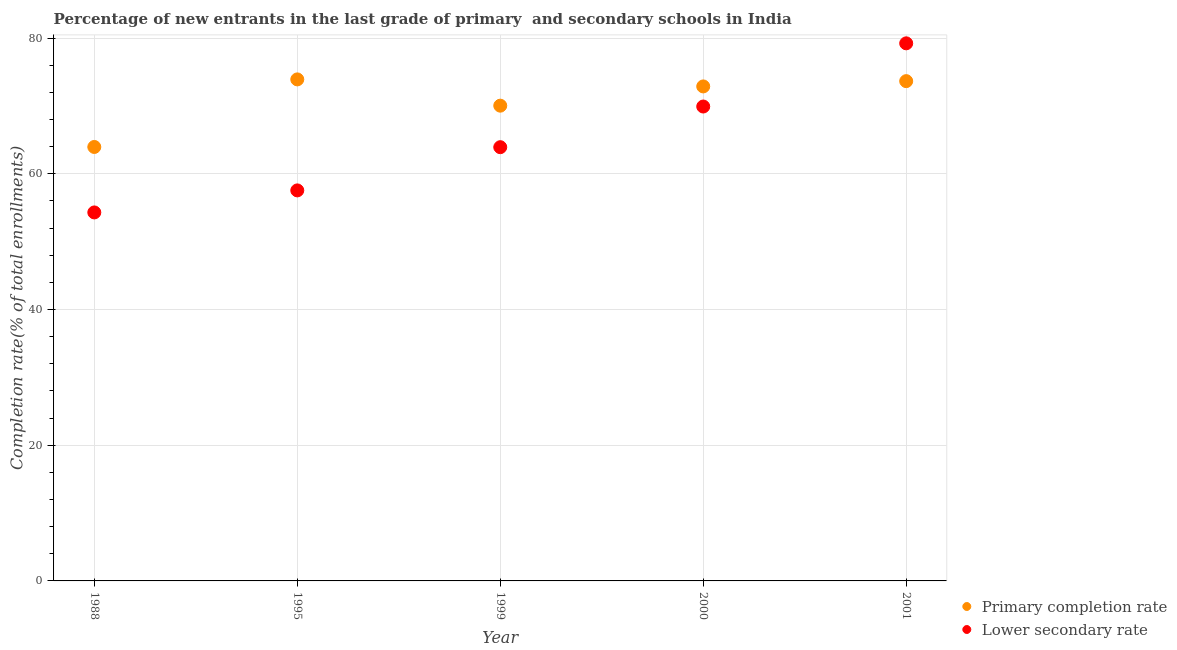How many different coloured dotlines are there?
Make the answer very short. 2. What is the completion rate in primary schools in 1988?
Your answer should be compact. 63.96. Across all years, what is the maximum completion rate in primary schools?
Provide a short and direct response. 73.92. Across all years, what is the minimum completion rate in secondary schools?
Your answer should be very brief. 54.31. In which year was the completion rate in primary schools minimum?
Your answer should be compact. 1988. What is the total completion rate in primary schools in the graph?
Offer a very short reply. 354.47. What is the difference between the completion rate in secondary schools in 1988 and that in 2000?
Offer a very short reply. -15.61. What is the difference between the completion rate in secondary schools in 2001 and the completion rate in primary schools in 1988?
Your answer should be very brief. 15.28. What is the average completion rate in primary schools per year?
Your answer should be very brief. 70.89. In the year 2001, what is the difference between the completion rate in primary schools and completion rate in secondary schools?
Offer a very short reply. -5.57. What is the ratio of the completion rate in primary schools in 1988 to that in 2001?
Keep it short and to the point. 0.87. Is the completion rate in secondary schools in 1988 less than that in 1995?
Your answer should be very brief. Yes. What is the difference between the highest and the second highest completion rate in secondary schools?
Give a very brief answer. 9.31. What is the difference between the highest and the lowest completion rate in primary schools?
Ensure brevity in your answer.  9.96. Is the sum of the completion rate in primary schools in 1999 and 2001 greater than the maximum completion rate in secondary schools across all years?
Give a very brief answer. Yes. Is the completion rate in secondary schools strictly greater than the completion rate in primary schools over the years?
Ensure brevity in your answer.  No. How many years are there in the graph?
Offer a terse response. 5. What is the difference between two consecutive major ticks on the Y-axis?
Give a very brief answer. 20. How are the legend labels stacked?
Provide a short and direct response. Vertical. What is the title of the graph?
Provide a succinct answer. Percentage of new entrants in the last grade of primary  and secondary schools in India. Does "Grants" appear as one of the legend labels in the graph?
Your answer should be compact. No. What is the label or title of the Y-axis?
Your response must be concise. Completion rate(% of total enrollments). What is the Completion rate(% of total enrollments) of Primary completion rate in 1988?
Provide a short and direct response. 63.96. What is the Completion rate(% of total enrollments) in Lower secondary rate in 1988?
Make the answer very short. 54.31. What is the Completion rate(% of total enrollments) of Primary completion rate in 1995?
Make the answer very short. 73.92. What is the Completion rate(% of total enrollments) in Lower secondary rate in 1995?
Offer a terse response. 57.56. What is the Completion rate(% of total enrollments) in Primary completion rate in 1999?
Offer a very short reply. 70.05. What is the Completion rate(% of total enrollments) of Lower secondary rate in 1999?
Your answer should be very brief. 63.93. What is the Completion rate(% of total enrollments) in Primary completion rate in 2000?
Provide a short and direct response. 72.88. What is the Completion rate(% of total enrollments) in Lower secondary rate in 2000?
Your response must be concise. 69.92. What is the Completion rate(% of total enrollments) of Primary completion rate in 2001?
Give a very brief answer. 73.66. What is the Completion rate(% of total enrollments) in Lower secondary rate in 2001?
Provide a short and direct response. 79.24. Across all years, what is the maximum Completion rate(% of total enrollments) in Primary completion rate?
Give a very brief answer. 73.92. Across all years, what is the maximum Completion rate(% of total enrollments) in Lower secondary rate?
Your answer should be compact. 79.24. Across all years, what is the minimum Completion rate(% of total enrollments) of Primary completion rate?
Offer a terse response. 63.96. Across all years, what is the minimum Completion rate(% of total enrollments) in Lower secondary rate?
Your answer should be very brief. 54.31. What is the total Completion rate(% of total enrollments) in Primary completion rate in the graph?
Your answer should be compact. 354.47. What is the total Completion rate(% of total enrollments) of Lower secondary rate in the graph?
Offer a terse response. 324.96. What is the difference between the Completion rate(% of total enrollments) of Primary completion rate in 1988 and that in 1995?
Your answer should be compact. -9.96. What is the difference between the Completion rate(% of total enrollments) of Lower secondary rate in 1988 and that in 1995?
Offer a very short reply. -3.25. What is the difference between the Completion rate(% of total enrollments) of Primary completion rate in 1988 and that in 1999?
Provide a short and direct response. -6.09. What is the difference between the Completion rate(% of total enrollments) of Lower secondary rate in 1988 and that in 1999?
Provide a short and direct response. -9.62. What is the difference between the Completion rate(% of total enrollments) in Primary completion rate in 1988 and that in 2000?
Your answer should be compact. -8.92. What is the difference between the Completion rate(% of total enrollments) of Lower secondary rate in 1988 and that in 2000?
Your response must be concise. -15.61. What is the difference between the Completion rate(% of total enrollments) in Primary completion rate in 1988 and that in 2001?
Your answer should be very brief. -9.7. What is the difference between the Completion rate(% of total enrollments) in Lower secondary rate in 1988 and that in 2001?
Your answer should be compact. -24.92. What is the difference between the Completion rate(% of total enrollments) of Primary completion rate in 1995 and that in 1999?
Keep it short and to the point. 3.87. What is the difference between the Completion rate(% of total enrollments) in Lower secondary rate in 1995 and that in 1999?
Your answer should be compact. -6.37. What is the difference between the Completion rate(% of total enrollments) of Primary completion rate in 1995 and that in 2000?
Make the answer very short. 1.04. What is the difference between the Completion rate(% of total enrollments) in Lower secondary rate in 1995 and that in 2000?
Provide a succinct answer. -12.36. What is the difference between the Completion rate(% of total enrollments) of Primary completion rate in 1995 and that in 2001?
Make the answer very short. 0.26. What is the difference between the Completion rate(% of total enrollments) of Lower secondary rate in 1995 and that in 2001?
Provide a short and direct response. -21.68. What is the difference between the Completion rate(% of total enrollments) in Primary completion rate in 1999 and that in 2000?
Ensure brevity in your answer.  -2.84. What is the difference between the Completion rate(% of total enrollments) in Lower secondary rate in 1999 and that in 2000?
Make the answer very short. -5.99. What is the difference between the Completion rate(% of total enrollments) in Primary completion rate in 1999 and that in 2001?
Keep it short and to the point. -3.62. What is the difference between the Completion rate(% of total enrollments) of Lower secondary rate in 1999 and that in 2001?
Ensure brevity in your answer.  -15.31. What is the difference between the Completion rate(% of total enrollments) in Primary completion rate in 2000 and that in 2001?
Your answer should be compact. -0.78. What is the difference between the Completion rate(% of total enrollments) in Lower secondary rate in 2000 and that in 2001?
Your answer should be very brief. -9.31. What is the difference between the Completion rate(% of total enrollments) of Primary completion rate in 1988 and the Completion rate(% of total enrollments) of Lower secondary rate in 1995?
Provide a succinct answer. 6.4. What is the difference between the Completion rate(% of total enrollments) of Primary completion rate in 1988 and the Completion rate(% of total enrollments) of Lower secondary rate in 1999?
Offer a very short reply. 0.03. What is the difference between the Completion rate(% of total enrollments) in Primary completion rate in 1988 and the Completion rate(% of total enrollments) in Lower secondary rate in 2000?
Your answer should be very brief. -5.96. What is the difference between the Completion rate(% of total enrollments) of Primary completion rate in 1988 and the Completion rate(% of total enrollments) of Lower secondary rate in 2001?
Offer a very short reply. -15.28. What is the difference between the Completion rate(% of total enrollments) of Primary completion rate in 1995 and the Completion rate(% of total enrollments) of Lower secondary rate in 1999?
Your response must be concise. 9.99. What is the difference between the Completion rate(% of total enrollments) of Primary completion rate in 1995 and the Completion rate(% of total enrollments) of Lower secondary rate in 2000?
Your answer should be compact. 4. What is the difference between the Completion rate(% of total enrollments) of Primary completion rate in 1995 and the Completion rate(% of total enrollments) of Lower secondary rate in 2001?
Keep it short and to the point. -5.32. What is the difference between the Completion rate(% of total enrollments) in Primary completion rate in 1999 and the Completion rate(% of total enrollments) in Lower secondary rate in 2000?
Your answer should be very brief. 0.13. What is the difference between the Completion rate(% of total enrollments) of Primary completion rate in 1999 and the Completion rate(% of total enrollments) of Lower secondary rate in 2001?
Provide a short and direct response. -9.19. What is the difference between the Completion rate(% of total enrollments) of Primary completion rate in 2000 and the Completion rate(% of total enrollments) of Lower secondary rate in 2001?
Your response must be concise. -6.35. What is the average Completion rate(% of total enrollments) in Primary completion rate per year?
Provide a short and direct response. 70.89. What is the average Completion rate(% of total enrollments) in Lower secondary rate per year?
Give a very brief answer. 64.99. In the year 1988, what is the difference between the Completion rate(% of total enrollments) in Primary completion rate and Completion rate(% of total enrollments) in Lower secondary rate?
Give a very brief answer. 9.65. In the year 1995, what is the difference between the Completion rate(% of total enrollments) in Primary completion rate and Completion rate(% of total enrollments) in Lower secondary rate?
Your response must be concise. 16.36. In the year 1999, what is the difference between the Completion rate(% of total enrollments) of Primary completion rate and Completion rate(% of total enrollments) of Lower secondary rate?
Make the answer very short. 6.12. In the year 2000, what is the difference between the Completion rate(% of total enrollments) in Primary completion rate and Completion rate(% of total enrollments) in Lower secondary rate?
Your answer should be very brief. 2.96. In the year 2001, what is the difference between the Completion rate(% of total enrollments) of Primary completion rate and Completion rate(% of total enrollments) of Lower secondary rate?
Offer a terse response. -5.57. What is the ratio of the Completion rate(% of total enrollments) in Primary completion rate in 1988 to that in 1995?
Your answer should be very brief. 0.87. What is the ratio of the Completion rate(% of total enrollments) of Lower secondary rate in 1988 to that in 1995?
Give a very brief answer. 0.94. What is the ratio of the Completion rate(% of total enrollments) in Primary completion rate in 1988 to that in 1999?
Offer a terse response. 0.91. What is the ratio of the Completion rate(% of total enrollments) of Lower secondary rate in 1988 to that in 1999?
Make the answer very short. 0.85. What is the ratio of the Completion rate(% of total enrollments) of Primary completion rate in 1988 to that in 2000?
Give a very brief answer. 0.88. What is the ratio of the Completion rate(% of total enrollments) in Lower secondary rate in 1988 to that in 2000?
Provide a short and direct response. 0.78. What is the ratio of the Completion rate(% of total enrollments) of Primary completion rate in 1988 to that in 2001?
Provide a short and direct response. 0.87. What is the ratio of the Completion rate(% of total enrollments) of Lower secondary rate in 1988 to that in 2001?
Your response must be concise. 0.69. What is the ratio of the Completion rate(% of total enrollments) in Primary completion rate in 1995 to that in 1999?
Offer a very short reply. 1.06. What is the ratio of the Completion rate(% of total enrollments) in Lower secondary rate in 1995 to that in 1999?
Offer a terse response. 0.9. What is the ratio of the Completion rate(% of total enrollments) in Primary completion rate in 1995 to that in 2000?
Your response must be concise. 1.01. What is the ratio of the Completion rate(% of total enrollments) of Lower secondary rate in 1995 to that in 2000?
Make the answer very short. 0.82. What is the ratio of the Completion rate(% of total enrollments) in Lower secondary rate in 1995 to that in 2001?
Your response must be concise. 0.73. What is the ratio of the Completion rate(% of total enrollments) in Primary completion rate in 1999 to that in 2000?
Offer a terse response. 0.96. What is the ratio of the Completion rate(% of total enrollments) of Lower secondary rate in 1999 to that in 2000?
Provide a succinct answer. 0.91. What is the ratio of the Completion rate(% of total enrollments) of Primary completion rate in 1999 to that in 2001?
Make the answer very short. 0.95. What is the ratio of the Completion rate(% of total enrollments) of Lower secondary rate in 1999 to that in 2001?
Offer a very short reply. 0.81. What is the ratio of the Completion rate(% of total enrollments) in Primary completion rate in 2000 to that in 2001?
Your answer should be compact. 0.99. What is the ratio of the Completion rate(% of total enrollments) of Lower secondary rate in 2000 to that in 2001?
Keep it short and to the point. 0.88. What is the difference between the highest and the second highest Completion rate(% of total enrollments) of Primary completion rate?
Your response must be concise. 0.26. What is the difference between the highest and the second highest Completion rate(% of total enrollments) in Lower secondary rate?
Your response must be concise. 9.31. What is the difference between the highest and the lowest Completion rate(% of total enrollments) in Primary completion rate?
Offer a terse response. 9.96. What is the difference between the highest and the lowest Completion rate(% of total enrollments) in Lower secondary rate?
Make the answer very short. 24.92. 